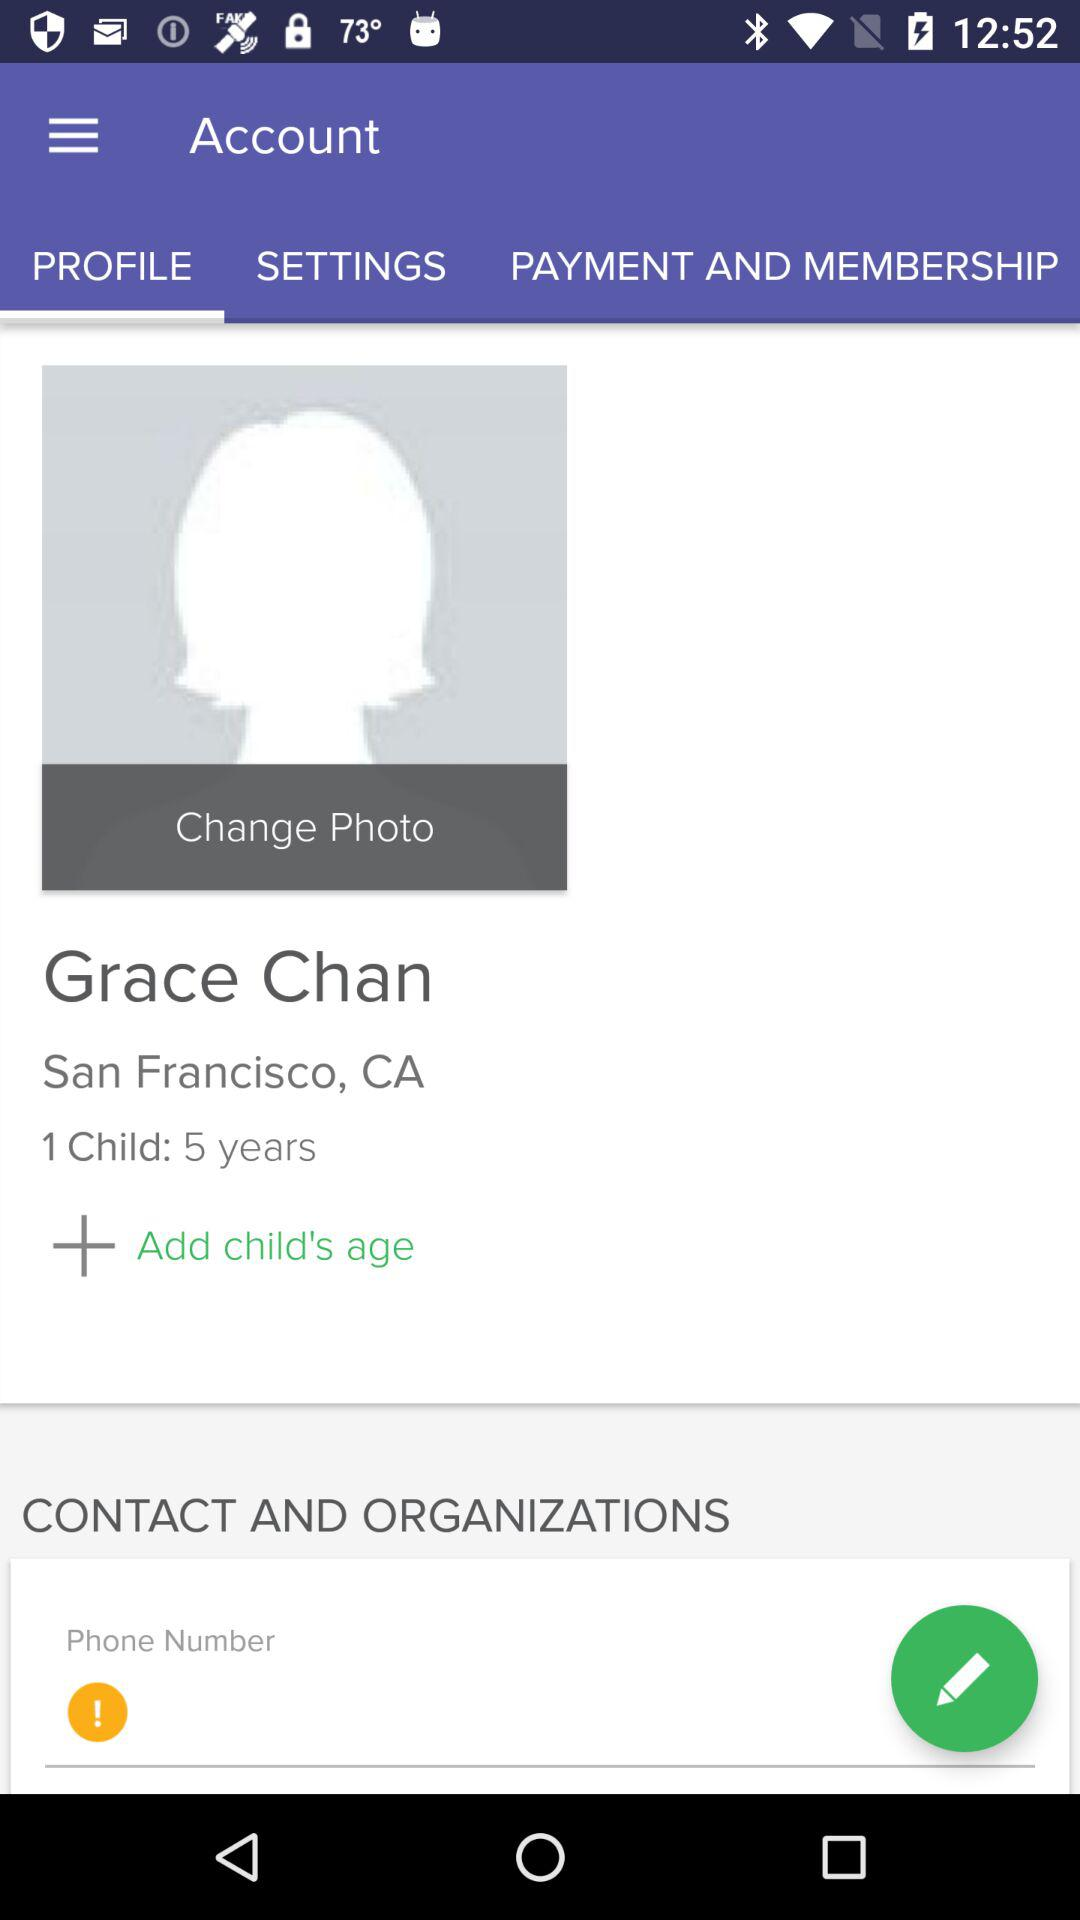How old is Grace Chan?
When the provided information is insufficient, respond with <no answer>. <no answer> 